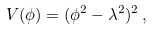<formula> <loc_0><loc_0><loc_500><loc_500>V ( \phi ) = ( \phi ^ { 2 } - \lambda ^ { 2 } ) ^ { 2 } \, ,</formula> 